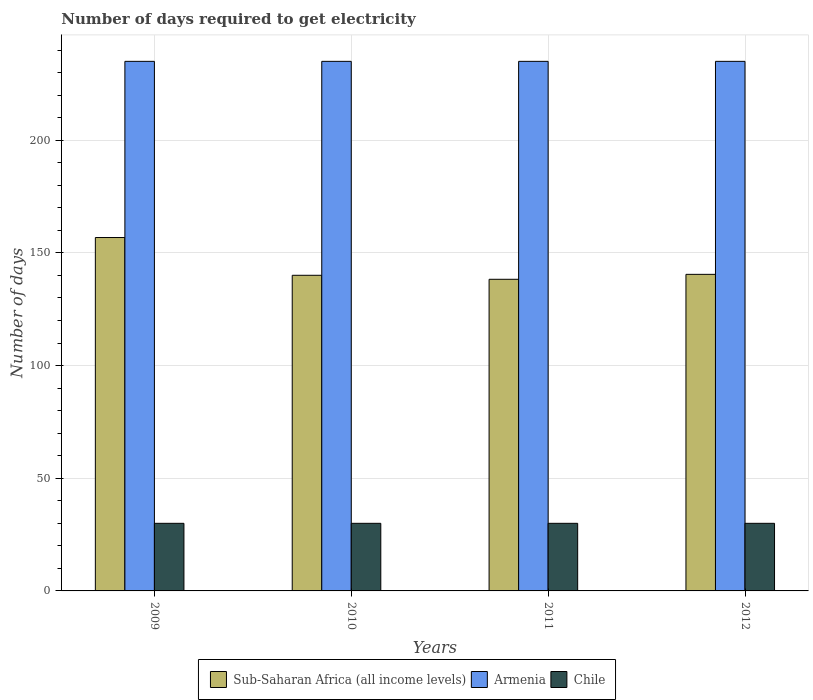How many groups of bars are there?
Provide a succinct answer. 4. Are the number of bars per tick equal to the number of legend labels?
Keep it short and to the point. Yes. How many bars are there on the 4th tick from the left?
Ensure brevity in your answer.  3. How many bars are there on the 1st tick from the right?
Make the answer very short. 3. What is the label of the 3rd group of bars from the left?
Your answer should be compact. 2011. In how many cases, is the number of bars for a given year not equal to the number of legend labels?
Your answer should be compact. 0. What is the number of days required to get electricity in in Armenia in 2010?
Ensure brevity in your answer.  235. Across all years, what is the maximum number of days required to get electricity in in Sub-Saharan Africa (all income levels)?
Keep it short and to the point. 156.82. Across all years, what is the minimum number of days required to get electricity in in Armenia?
Keep it short and to the point. 235. What is the total number of days required to get electricity in in Sub-Saharan Africa (all income levels) in the graph?
Your answer should be compact. 575.66. What is the difference between the number of days required to get electricity in in Sub-Saharan Africa (all income levels) in 2010 and that in 2012?
Your response must be concise. -0.41. What is the difference between the number of days required to get electricity in in Sub-Saharan Africa (all income levels) in 2009 and the number of days required to get electricity in in Chile in 2012?
Offer a terse response. 126.82. In the year 2010, what is the difference between the number of days required to get electricity in in Chile and number of days required to get electricity in in Sub-Saharan Africa (all income levels)?
Provide a short and direct response. -110.07. In how many years, is the number of days required to get electricity in in Armenia greater than 40 days?
Give a very brief answer. 4. What is the ratio of the number of days required to get electricity in in Sub-Saharan Africa (all income levels) in 2009 to that in 2012?
Your answer should be very brief. 1.12. What is the difference between the highest and the second highest number of days required to get electricity in in Armenia?
Make the answer very short. 0. What is the difference between the highest and the lowest number of days required to get electricity in in Sub-Saharan Africa (all income levels)?
Your answer should be very brief. 18.53. In how many years, is the number of days required to get electricity in in Chile greater than the average number of days required to get electricity in in Chile taken over all years?
Ensure brevity in your answer.  0. Is the sum of the number of days required to get electricity in in Chile in 2010 and 2011 greater than the maximum number of days required to get electricity in in Armenia across all years?
Keep it short and to the point. No. What does the 2nd bar from the left in 2012 represents?
Your answer should be compact. Armenia. What does the 3rd bar from the right in 2011 represents?
Offer a terse response. Sub-Saharan Africa (all income levels). Is it the case that in every year, the sum of the number of days required to get electricity in in Sub-Saharan Africa (all income levels) and number of days required to get electricity in in Chile is greater than the number of days required to get electricity in in Armenia?
Keep it short and to the point. No. How many bars are there?
Provide a succinct answer. 12. How many years are there in the graph?
Provide a succinct answer. 4. What is the difference between two consecutive major ticks on the Y-axis?
Give a very brief answer. 50. Are the values on the major ticks of Y-axis written in scientific E-notation?
Offer a very short reply. No. Does the graph contain grids?
Your answer should be compact. Yes. How many legend labels are there?
Offer a terse response. 3. What is the title of the graph?
Provide a short and direct response. Number of days required to get electricity. What is the label or title of the X-axis?
Your answer should be very brief. Years. What is the label or title of the Y-axis?
Provide a succinct answer. Number of days. What is the Number of days of Sub-Saharan Africa (all income levels) in 2009?
Provide a succinct answer. 156.82. What is the Number of days of Armenia in 2009?
Your response must be concise. 235. What is the Number of days in Sub-Saharan Africa (all income levels) in 2010?
Offer a very short reply. 140.07. What is the Number of days in Armenia in 2010?
Provide a short and direct response. 235. What is the Number of days in Sub-Saharan Africa (all income levels) in 2011?
Keep it short and to the point. 138.29. What is the Number of days of Armenia in 2011?
Make the answer very short. 235. What is the Number of days of Chile in 2011?
Keep it short and to the point. 30. What is the Number of days in Sub-Saharan Africa (all income levels) in 2012?
Keep it short and to the point. 140.48. What is the Number of days of Armenia in 2012?
Your answer should be very brief. 235. Across all years, what is the maximum Number of days in Sub-Saharan Africa (all income levels)?
Your answer should be compact. 156.82. Across all years, what is the maximum Number of days of Armenia?
Provide a short and direct response. 235. Across all years, what is the minimum Number of days of Sub-Saharan Africa (all income levels)?
Provide a succinct answer. 138.29. Across all years, what is the minimum Number of days of Armenia?
Make the answer very short. 235. Across all years, what is the minimum Number of days of Chile?
Offer a very short reply. 30. What is the total Number of days of Sub-Saharan Africa (all income levels) in the graph?
Ensure brevity in your answer.  575.66. What is the total Number of days in Armenia in the graph?
Provide a short and direct response. 940. What is the total Number of days in Chile in the graph?
Your response must be concise. 120. What is the difference between the Number of days of Sub-Saharan Africa (all income levels) in 2009 and that in 2010?
Offer a very short reply. 16.76. What is the difference between the Number of days in Armenia in 2009 and that in 2010?
Give a very brief answer. 0. What is the difference between the Number of days in Sub-Saharan Africa (all income levels) in 2009 and that in 2011?
Give a very brief answer. 18.53. What is the difference between the Number of days in Armenia in 2009 and that in 2011?
Make the answer very short. 0. What is the difference between the Number of days of Chile in 2009 and that in 2011?
Your answer should be very brief. 0. What is the difference between the Number of days of Sub-Saharan Africa (all income levels) in 2009 and that in 2012?
Make the answer very short. 16.34. What is the difference between the Number of days of Sub-Saharan Africa (all income levels) in 2010 and that in 2011?
Provide a succinct answer. 1.78. What is the difference between the Number of days in Sub-Saharan Africa (all income levels) in 2010 and that in 2012?
Make the answer very short. -0.41. What is the difference between the Number of days in Armenia in 2010 and that in 2012?
Keep it short and to the point. 0. What is the difference between the Number of days in Chile in 2010 and that in 2012?
Your response must be concise. 0. What is the difference between the Number of days of Sub-Saharan Africa (all income levels) in 2011 and that in 2012?
Your response must be concise. -2.19. What is the difference between the Number of days of Sub-Saharan Africa (all income levels) in 2009 and the Number of days of Armenia in 2010?
Keep it short and to the point. -78.18. What is the difference between the Number of days in Sub-Saharan Africa (all income levels) in 2009 and the Number of days in Chile in 2010?
Keep it short and to the point. 126.82. What is the difference between the Number of days in Armenia in 2009 and the Number of days in Chile in 2010?
Provide a succinct answer. 205. What is the difference between the Number of days in Sub-Saharan Africa (all income levels) in 2009 and the Number of days in Armenia in 2011?
Make the answer very short. -78.18. What is the difference between the Number of days of Sub-Saharan Africa (all income levels) in 2009 and the Number of days of Chile in 2011?
Your answer should be very brief. 126.82. What is the difference between the Number of days of Armenia in 2009 and the Number of days of Chile in 2011?
Your answer should be compact. 205. What is the difference between the Number of days in Sub-Saharan Africa (all income levels) in 2009 and the Number of days in Armenia in 2012?
Make the answer very short. -78.18. What is the difference between the Number of days in Sub-Saharan Africa (all income levels) in 2009 and the Number of days in Chile in 2012?
Provide a short and direct response. 126.82. What is the difference between the Number of days in Armenia in 2009 and the Number of days in Chile in 2012?
Provide a short and direct response. 205. What is the difference between the Number of days of Sub-Saharan Africa (all income levels) in 2010 and the Number of days of Armenia in 2011?
Make the answer very short. -94.93. What is the difference between the Number of days in Sub-Saharan Africa (all income levels) in 2010 and the Number of days in Chile in 2011?
Keep it short and to the point. 110.07. What is the difference between the Number of days of Armenia in 2010 and the Number of days of Chile in 2011?
Ensure brevity in your answer.  205. What is the difference between the Number of days in Sub-Saharan Africa (all income levels) in 2010 and the Number of days in Armenia in 2012?
Your response must be concise. -94.93. What is the difference between the Number of days in Sub-Saharan Africa (all income levels) in 2010 and the Number of days in Chile in 2012?
Your answer should be compact. 110.07. What is the difference between the Number of days in Armenia in 2010 and the Number of days in Chile in 2012?
Provide a succinct answer. 205. What is the difference between the Number of days in Sub-Saharan Africa (all income levels) in 2011 and the Number of days in Armenia in 2012?
Provide a succinct answer. -96.71. What is the difference between the Number of days of Sub-Saharan Africa (all income levels) in 2011 and the Number of days of Chile in 2012?
Provide a succinct answer. 108.29. What is the difference between the Number of days in Armenia in 2011 and the Number of days in Chile in 2012?
Provide a succinct answer. 205. What is the average Number of days of Sub-Saharan Africa (all income levels) per year?
Your answer should be compact. 143.91. What is the average Number of days of Armenia per year?
Make the answer very short. 235. What is the average Number of days of Chile per year?
Give a very brief answer. 30. In the year 2009, what is the difference between the Number of days of Sub-Saharan Africa (all income levels) and Number of days of Armenia?
Provide a short and direct response. -78.18. In the year 2009, what is the difference between the Number of days in Sub-Saharan Africa (all income levels) and Number of days in Chile?
Your response must be concise. 126.82. In the year 2009, what is the difference between the Number of days of Armenia and Number of days of Chile?
Offer a terse response. 205. In the year 2010, what is the difference between the Number of days in Sub-Saharan Africa (all income levels) and Number of days in Armenia?
Ensure brevity in your answer.  -94.93. In the year 2010, what is the difference between the Number of days of Sub-Saharan Africa (all income levels) and Number of days of Chile?
Keep it short and to the point. 110.07. In the year 2010, what is the difference between the Number of days in Armenia and Number of days in Chile?
Offer a very short reply. 205. In the year 2011, what is the difference between the Number of days in Sub-Saharan Africa (all income levels) and Number of days in Armenia?
Provide a succinct answer. -96.71. In the year 2011, what is the difference between the Number of days in Sub-Saharan Africa (all income levels) and Number of days in Chile?
Make the answer very short. 108.29. In the year 2011, what is the difference between the Number of days in Armenia and Number of days in Chile?
Keep it short and to the point. 205. In the year 2012, what is the difference between the Number of days in Sub-Saharan Africa (all income levels) and Number of days in Armenia?
Make the answer very short. -94.52. In the year 2012, what is the difference between the Number of days in Sub-Saharan Africa (all income levels) and Number of days in Chile?
Your response must be concise. 110.48. In the year 2012, what is the difference between the Number of days of Armenia and Number of days of Chile?
Provide a short and direct response. 205. What is the ratio of the Number of days in Sub-Saharan Africa (all income levels) in 2009 to that in 2010?
Ensure brevity in your answer.  1.12. What is the ratio of the Number of days in Armenia in 2009 to that in 2010?
Ensure brevity in your answer.  1. What is the ratio of the Number of days in Chile in 2009 to that in 2010?
Offer a very short reply. 1. What is the ratio of the Number of days in Sub-Saharan Africa (all income levels) in 2009 to that in 2011?
Give a very brief answer. 1.13. What is the ratio of the Number of days in Sub-Saharan Africa (all income levels) in 2009 to that in 2012?
Your answer should be very brief. 1.12. What is the ratio of the Number of days in Armenia in 2009 to that in 2012?
Offer a terse response. 1. What is the ratio of the Number of days of Chile in 2009 to that in 2012?
Ensure brevity in your answer.  1. What is the ratio of the Number of days in Sub-Saharan Africa (all income levels) in 2010 to that in 2011?
Offer a terse response. 1.01. What is the ratio of the Number of days of Armenia in 2010 to that in 2011?
Give a very brief answer. 1. What is the ratio of the Number of days in Chile in 2010 to that in 2011?
Ensure brevity in your answer.  1. What is the ratio of the Number of days of Sub-Saharan Africa (all income levels) in 2011 to that in 2012?
Ensure brevity in your answer.  0.98. What is the difference between the highest and the second highest Number of days in Sub-Saharan Africa (all income levels)?
Provide a succinct answer. 16.34. What is the difference between the highest and the lowest Number of days in Sub-Saharan Africa (all income levels)?
Your response must be concise. 18.53. 